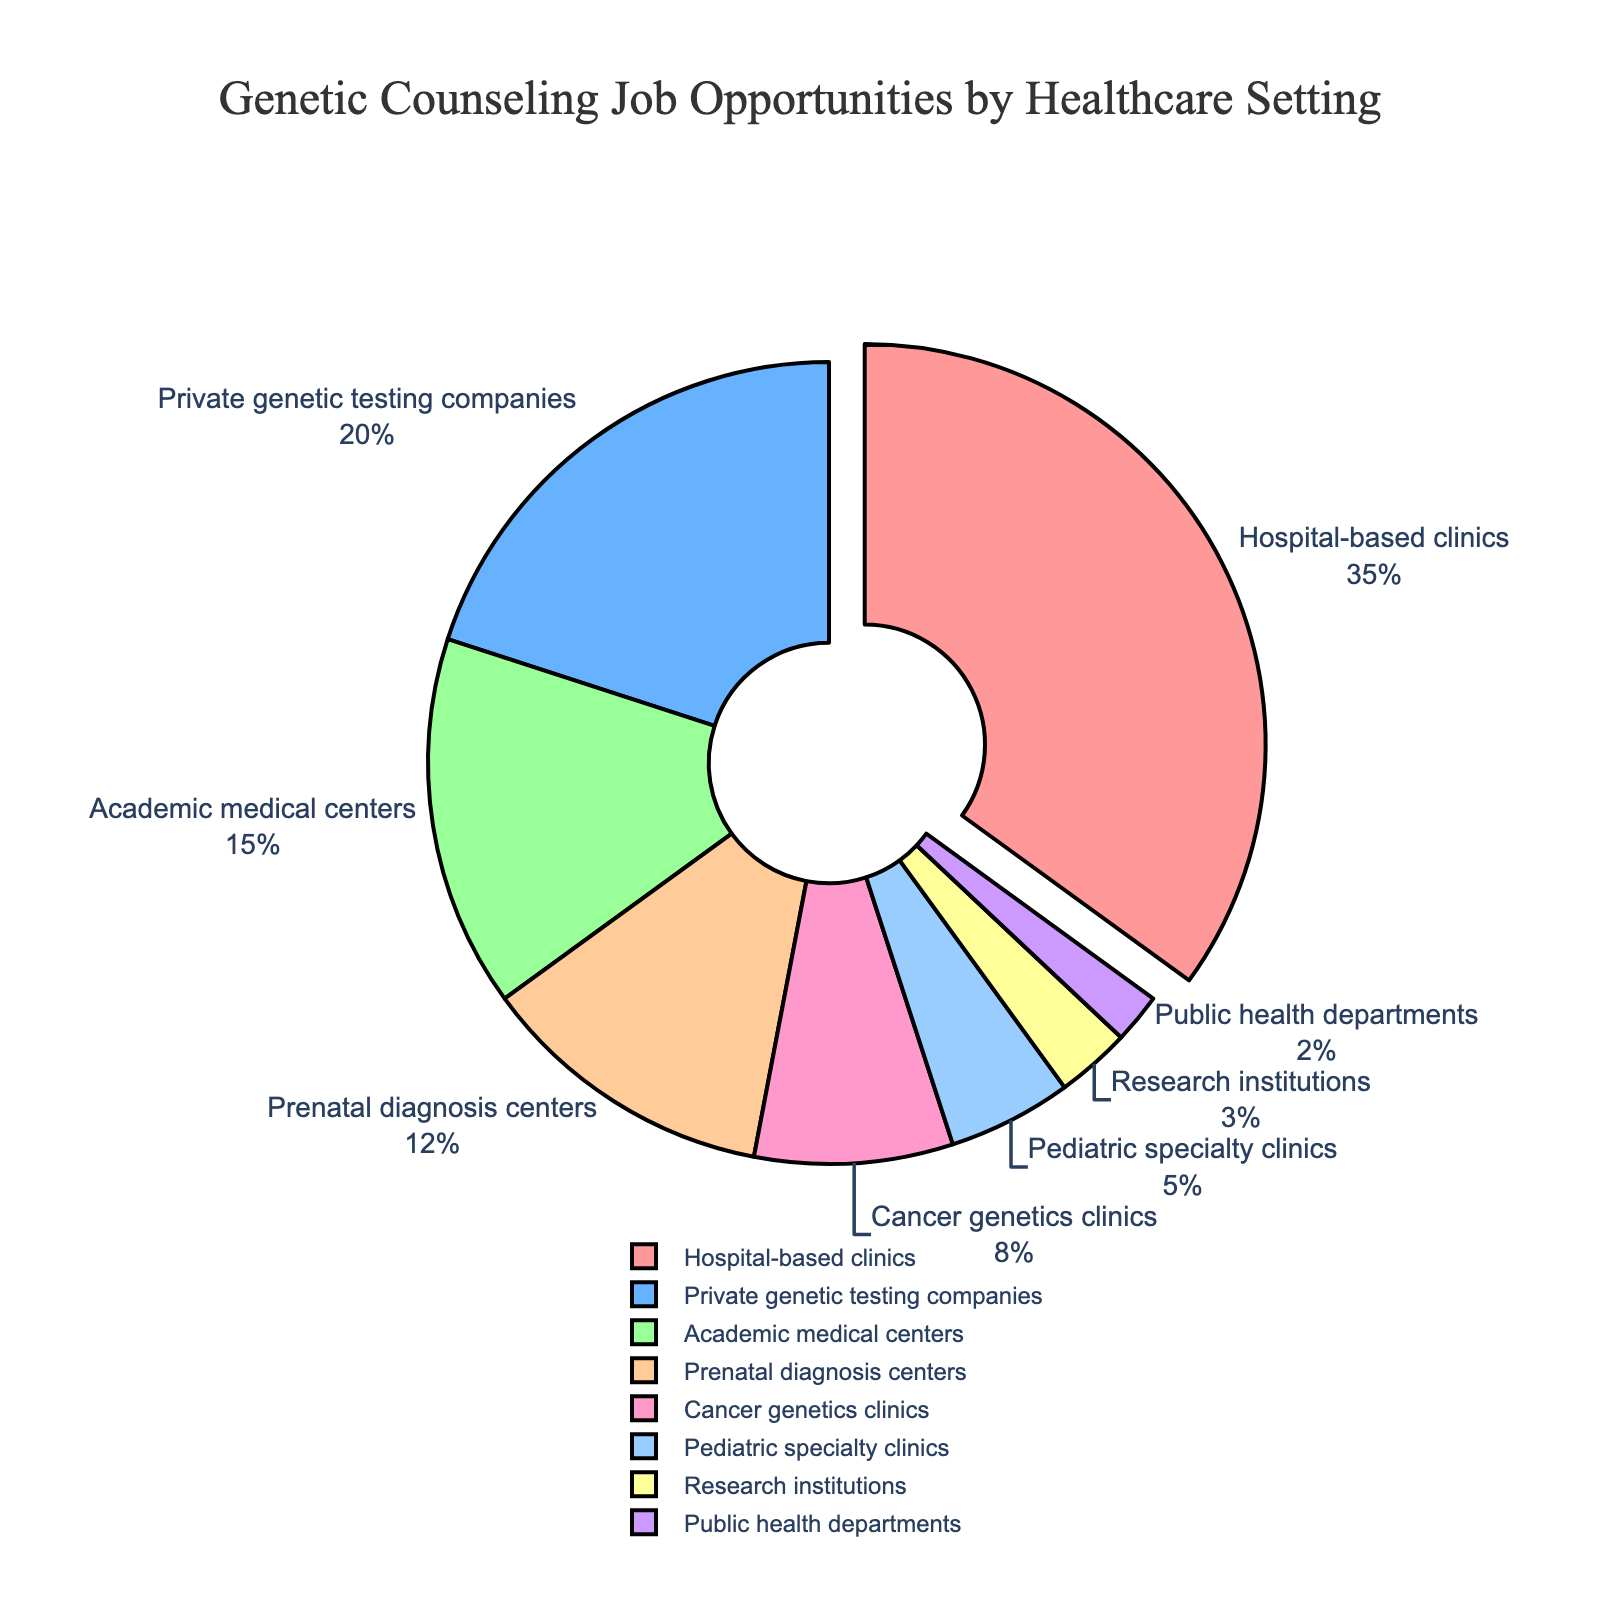Which healthcare setting has the highest percentage of genetic counseling job opportunities? The slice of the pie chart that is pulled out represents the highest percentage. By examining the chart, "Hospital-based clinics" stands out.
Answer: Hospital-based clinics What is the percentage difference between job opportunities in hospital-based clinics and private genetic testing companies? The percentage for hospital-based clinics is 35%, and for private genetic testing companies, it is 20%. The difference is calculated as 35% - 20%.
Answer: 15% Which three healthcare settings together make up more than half of the job opportunities? Adding the percentages, Hospital-based clinics (35%) + Private genetic testing companies (20%) + Academic medical centers (15%) equals 70%, which is more than half (50%).
Answer: Hospital-based clinics, Private genetic testing companies, Academic medical centers How many healthcare settings have less than a 10% share of genetic counseling job opportunities? The slices representing Cancer genetics clinics (8%), Pediatric specialty clinics (5%), Research institutions (3%), and Public health departments (2%) all have less than 10% each.
Answer: 4 Which slice of the pie chart is colored in blue, and what is its corresponding percentage? By examining the color distribution in the pie chart, the blue slice corresponds to Private genetic testing companies. Its percentage is given by the label alongside the slice.
Answer: Private genetic testing companies, 20% What is the combined percentage for pediatric specialty clinics and research institutions? Adding the percentages for Pediatric specialty clinics (5%) and Research Institutions (3%), we get 5% + 3%.
Answer: 8% How does the size of prenatal diagnosis centers compare to that of cancer genetics clinics in terms of percentage? Prenatal diagnosis centers have 12%, while Cancer genetics clinics have 8%. By comparing these percentages, Prenatal diagnosis centers have a higher percentage.
Answer: Prenatal diagnosis centers > Cancer genetics clinics If the second largest pie slice was to be combined with the smallest slice, what would their total percentage be? The second largest slice is Private genetic testing companies (20%). The smallest slice is Public health departments (2%). Combined, 20% + 2%.
Answer: 22% Which healthcare setting has the smallest share of genetic counseling job opportunities, and what fraction of the largest slice's percentage is it? Public health departments have the smallest share at 2%. The largest slice is Hospital-based clinics at 35%. The fraction is 2/35.
Answer: Public health departments, 2/35 If "Academic medical centers" and "Cancer genetics clinics" were grouped together, how would their combined percentage compare to "Private genetic testing companies"? Academic medical centers hold 15%, and Cancer genetics clinics hold 8%. Combined, they total 15% + 8% = 23%. Private genetic testing companies hold 20%. Therefore, the combined percentage is 23% - 20% = 3% more.
Answer: 3% more 